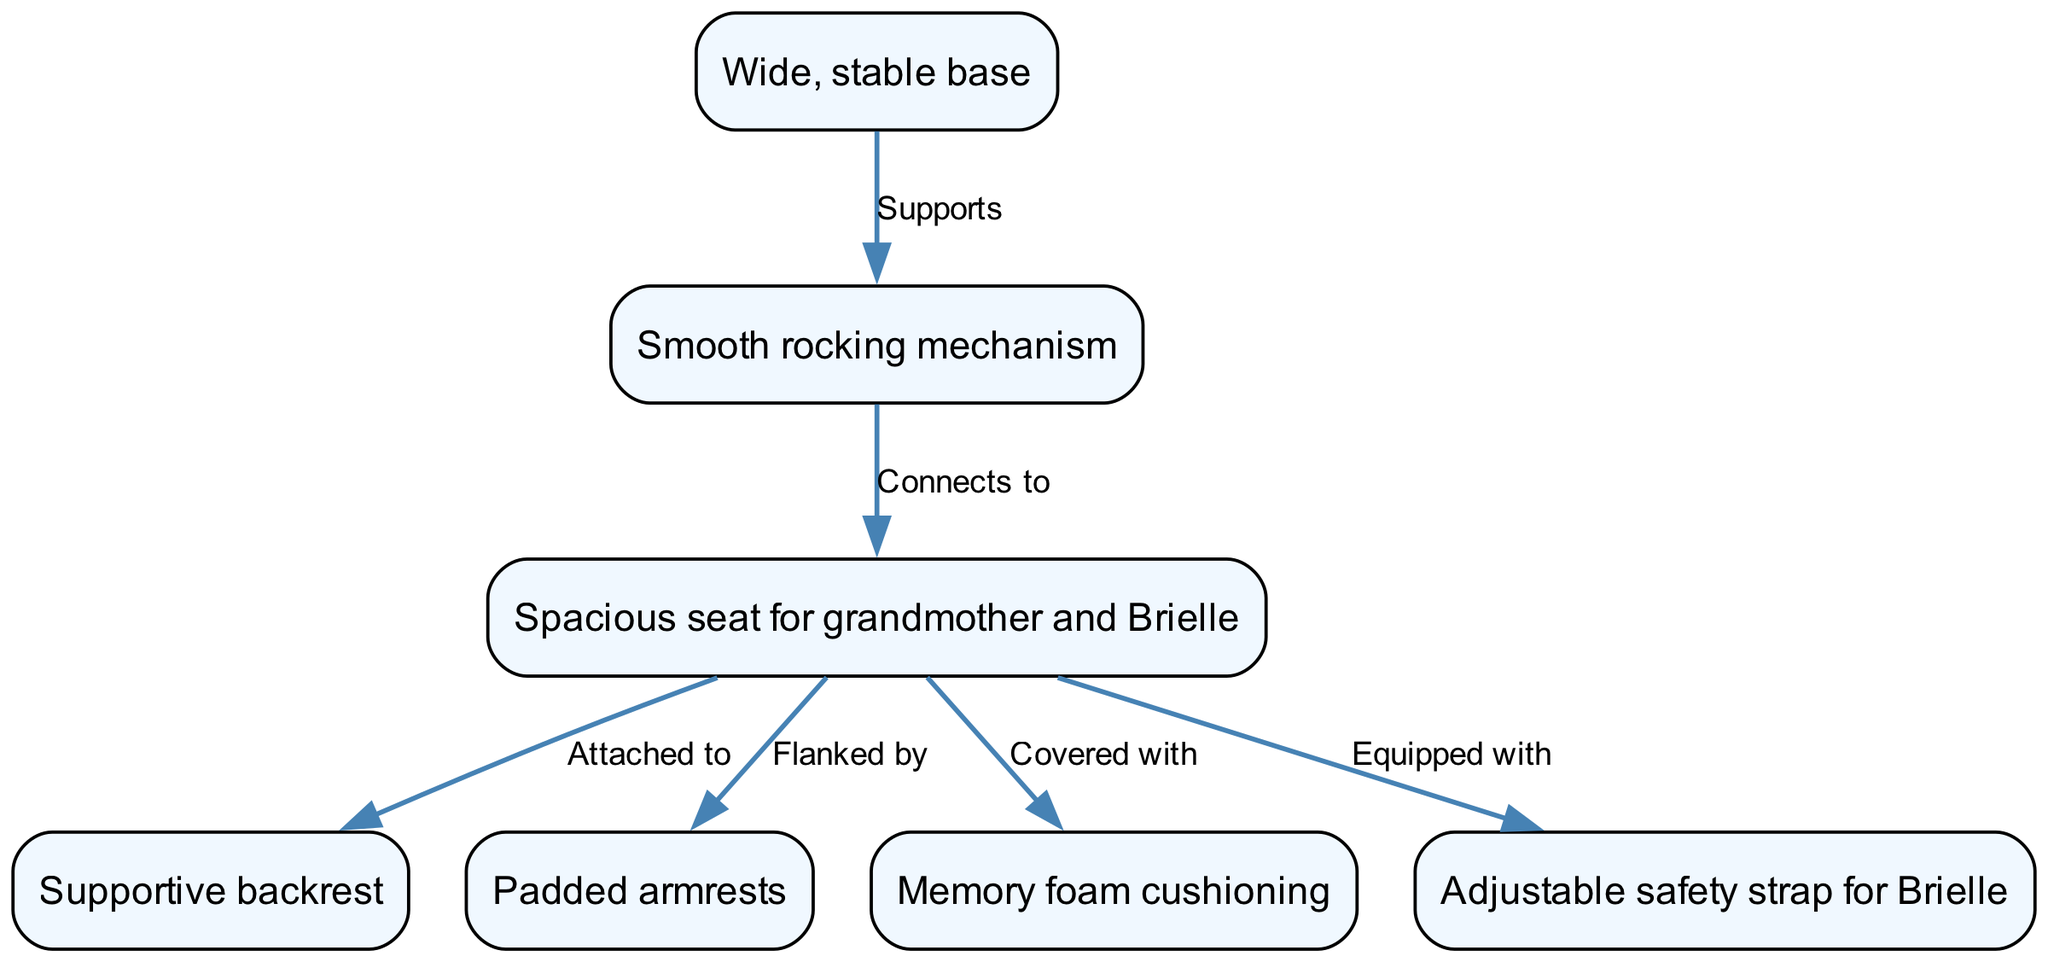What is the label of the node that represents the chair's main support? The label of the node representing the chair's main support is derived directly from the node's attributes in the diagram. The node with the id "chair_base" has the label "Wide, stable base," which signifies its function as the primary support structure.
Answer: Wide, stable base How many nodes are in the diagram? To find the number of nodes, we count the individual nodes listed in the diagram data. There are 7 distinct nodes representing different components of the ergonomic rocking chair design.
Answer: 7 What does the seat connect to in this design? The seat's connections can be traced through the edges that link it to other components. The diagram indicates that the seat connects to the backrest, armrests, cushioning, and safety strap. Therefore, the main connection highlighted in the question focuses on one specific relationship, which is with the backrest.
Answer: Backrest Which component does the safety strap belong to? The safety strap's association is indicated by the edge connecting it to the seat. According to the relationships defined in the diagram, the safety strap is equipped with the seat component, establishing its designated placement and purpose.
Answer: Seat What is the purpose of the padded armrests? The description of the padded armrests can be found in the node labeled "armrests." The diagram does not provide further contextual information about their specific purpose, but it inherently suggests comfort and support for the user, in this case, fulfilling a pleasant bonding experience with Brielle. Thus the concise purpose can be inferred from their label.
Answer: Comfort Which component supports the rocking mechanism? The relationship between nodes is explicit through the directed edges in the diagram. According to the directed edge from "chair_base" to "rocking_mechanism," it indicates that the wide, stable base supports the rocking mechanism, which is critical for the chair's functionality.
Answer: Chair base How is the seat cushioned? The cushioning for the seat is detailed in the relationship defined in the diagram. The edge suggests that the seat is covered with a specific type of cushioning, which is memory foam. This design choice enhances comfort for the grandmother and granddaughter.
Answer: Memory foam cushioning 